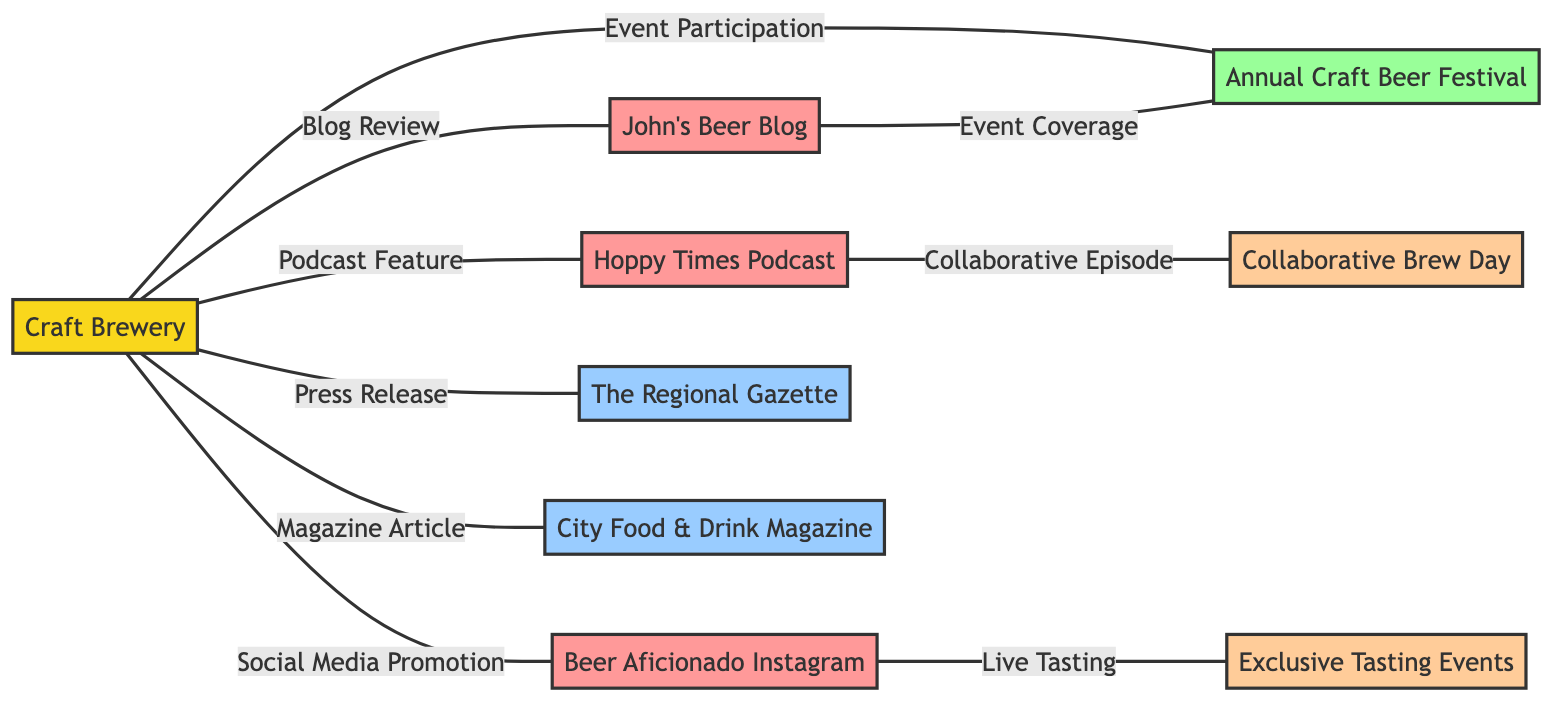What is the total number of nodes in the diagram? The nodes are: Craft Brewery, John's Beer Blog, Hoppy Times Podcast, Beer Aficionado Instagram, The Regional Gazette, City Food & Drink Magazine, Annual Craft Beer Festival, Exclusive Tasting Events, and Collaborative Brew Day. Counting these yields a total of 9 nodes.
Answer: 9 Which local influencer is associated with the event coverage? The event coverage is provided by John's Beer Blog, as indicated by the edge labeled "Event Coverage" connecting local_influencer_1 to event_1.
Answer: John's Beer Blog What type of relationship exists between the Craft Brewery and Hoppy Times Podcast? The relationship between Craft Brewery and Hoppy Times Podcast is characterized by the edge labeled "Podcast Feature", which indicates a promotional interaction primarily through a podcast.
Answer: Podcast Feature How many promotional efforts are listed in the diagram? The promotional efforts include Exclusive Tasting Events and Collaborative Brew Day, which are the two edges connected to the local influencers. Therefore, there are 2 promotional efforts within the diagram.
Answer: 2 Which media outlet is linked to a magazine article? The media outlet that is associated with a magazine article is City Food & Drink Magazine, as shown in the diagram where it is connected to the Craft Brewery by the edge labeled "Magazine Article".
Answer: City Food & Drink Magazine Which influencer is associated with the live tasting event? Beer Aficionado Instagram is associated with the live tasting event, as indicated by the edge labeled "Live Tasting" that connects local_influencer_3 to the promotional effort Exclusive Tasting Events.
Answer: Beer Aficionado Instagram What is the relationship between the Craft Brewery and the Annual Craft Beer Festival? The relationship is indicated by the edge labeled "Event Participation", connecting the Craft Brewery to the Annual Craft Beer Festival, signifying the Brewery's involvement in the festival.
Answer: Event Participation Which promotional effort is connected to Hoppy Times Podcast? The connection to Hoppy Times Podcast comes through the edge labeled "Collaborative Episode", which links the Hoppy Times Podcast to the Collaborative Brew Day promotional effort.
Answer: Collaborative Brew Day How many edges are present in the diagram? Counting all the connections between nodes, we find the edges: Blog Review, Podcast Feature, Social Media Promotion, Press Release, Magazine Article, Event Participation, Event Coverage, Live Tasting, and Collaborative Episode. This results in a total of 9 edges in the diagram.
Answer: 9 